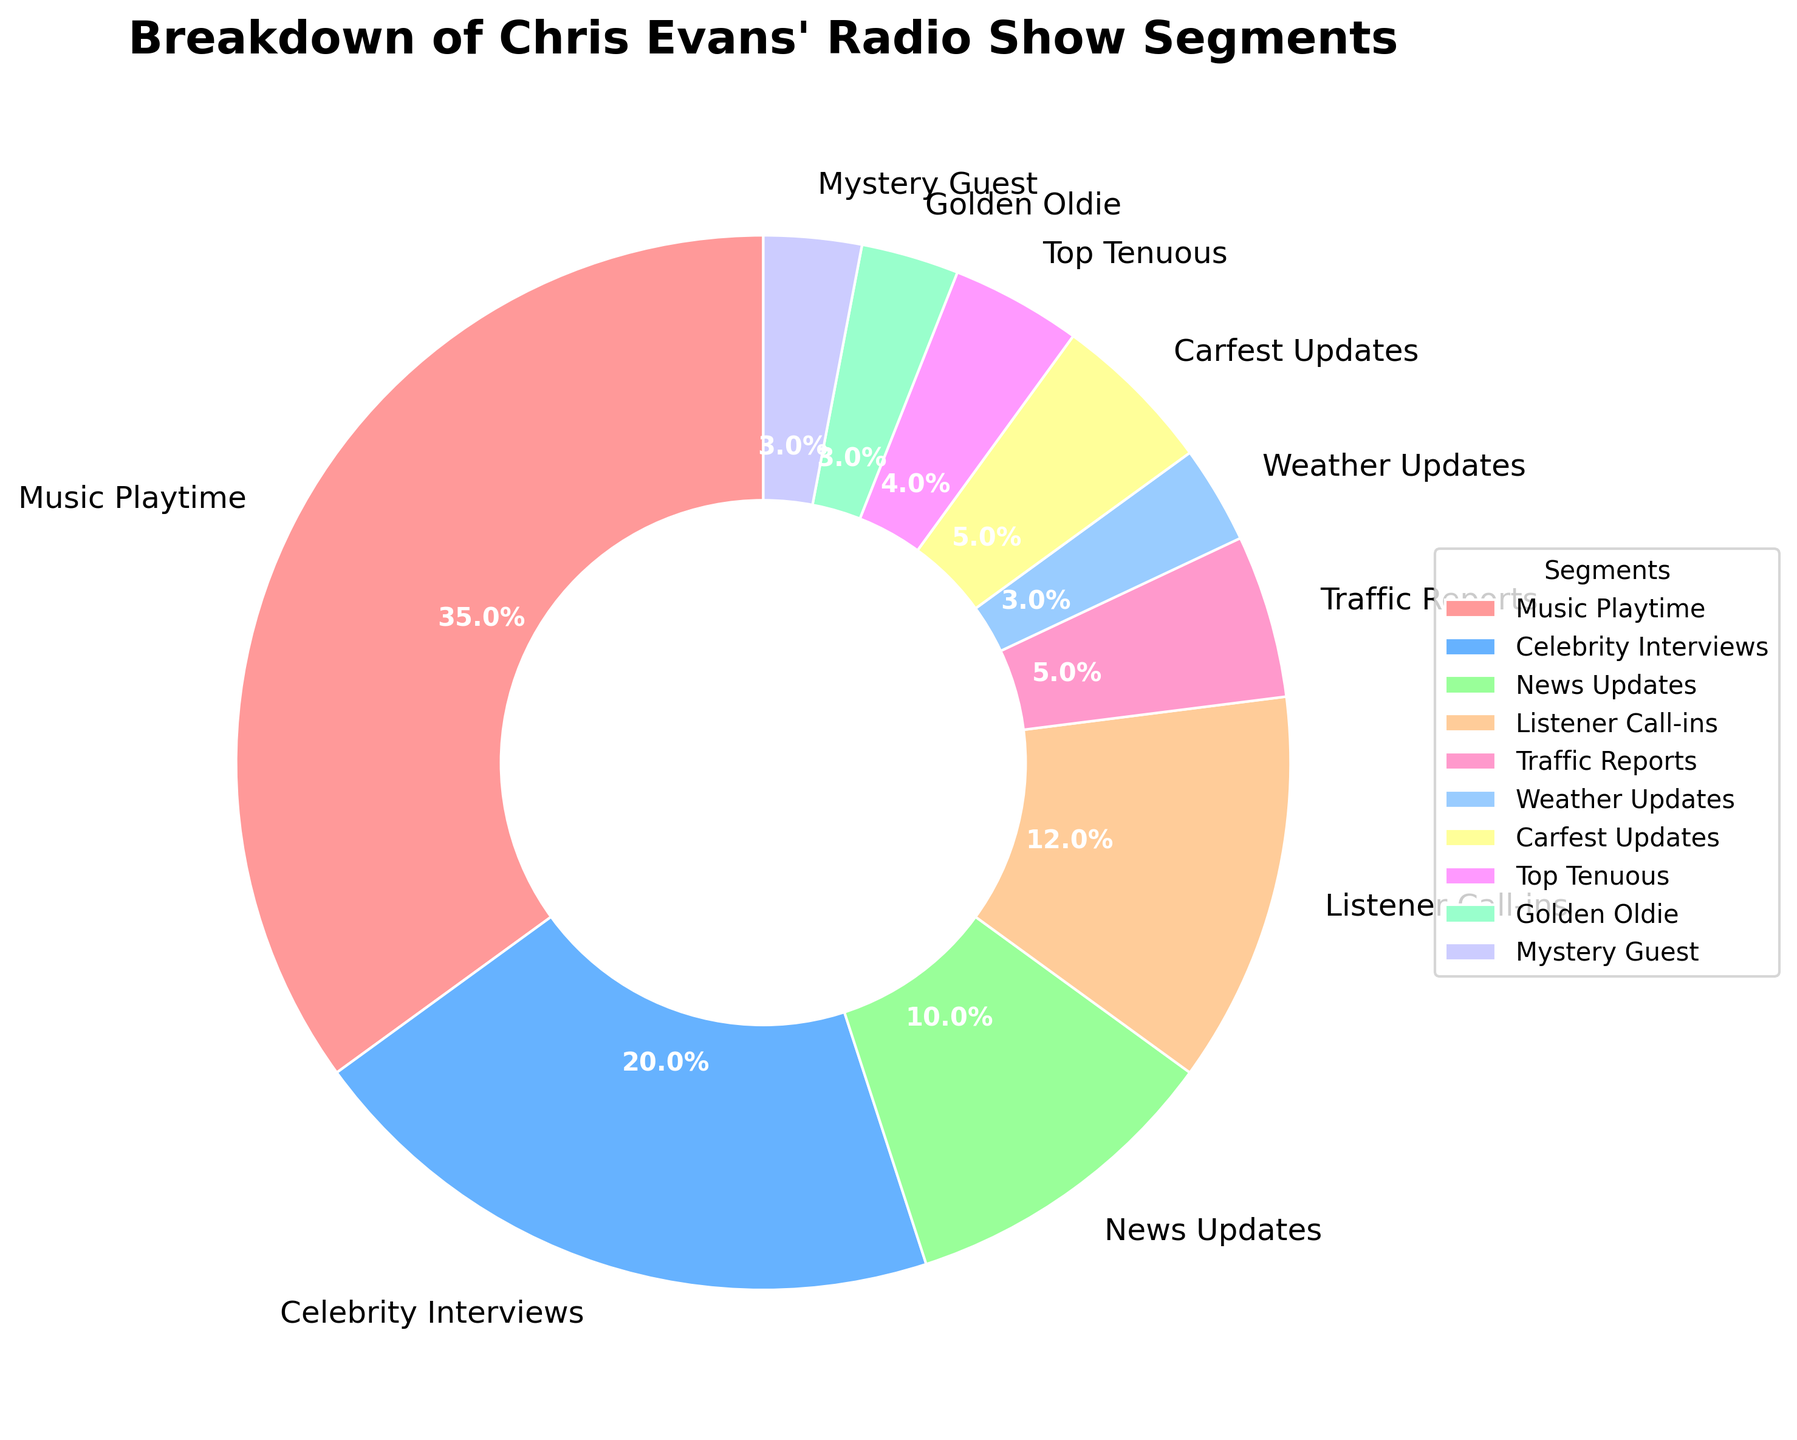Which segment takes up the largest portion of Chris Evans' radio show? By looking at the pie chart, we can see that the largest wedge, representing the largest percentage, is Music Playtime with 35%.
Answer: Music Playtime Which two segments combined make up the same percentage as the Music Playtime segment? Adding the percentages of Celebrity Interviews (20%) and Listener Call-ins (12%) gives us 32%, which is close to but not equal to Music Playtime. Adding Celebrity Interviews (20%) and Top Tenuous (4%) also gives 24%, which is also not equal to Music Playtime. Adding Listener Call-ins (12%) and News Updates (10%) gives us 22%, also not a match. Adding Listener Call-ins (12%) to Traffic Reports (5%), we get 17%. The segments that sum up to 35% are News Updates (10%), Listener Call-ins (12%), Top Tenuous (4%), and Golden Oldie (3%), adding up to 29%.
Answer: None, no two segments sum up to 35% exactly What percentage of the show is dedicated to Carfest Updates? By referring to the chart, the Carfest Updates segment is marked as 5% of the total show.
Answer: 5% How do the percentages for Weather Updates and Mystery Guest compare? The pie chart shows that both Weather Updates and Mystery Guest each account for 3% of the show, making them equal.
Answer: They are equal What is the total percentage of time dedicated to Music Playtime, Celebrity Interviews, and News Updates? Summing up the individual percentages: Music Playtime (35%), Celebrity Interviews (20%), and News Updates (10%), we get 35 + 20 + 10 = 65%.
Answer: 65% Which segment is represented by the lightest shade of red, and what is its percentage? By examining the colors, the lightest shade of red corresponds to Traffic Reports, which takes up 5% of the show.
Answer: Traffic Reports, 5% How much more percentage does Listener Call-ins have compared to Golden Oldie? Listener Call-ins account for 12% of the show, while Golden Oldie accounts for 3%. The difference is 12 - 3 = 9%.
Answer: 9% What's the percentage sum for all segments that occupy less than 5% each? Segments occupying less than 5% are Traffic Reports (5%), Weather Updates (3%), Carfest Updates (5%), Top Tenuous (4%), Golden Oldie (3%), and Mystery Guest (3%). Adding them up: 5 + 3 + 5 + 4 + 3 + 3 = 23%.
Answer: 23% 